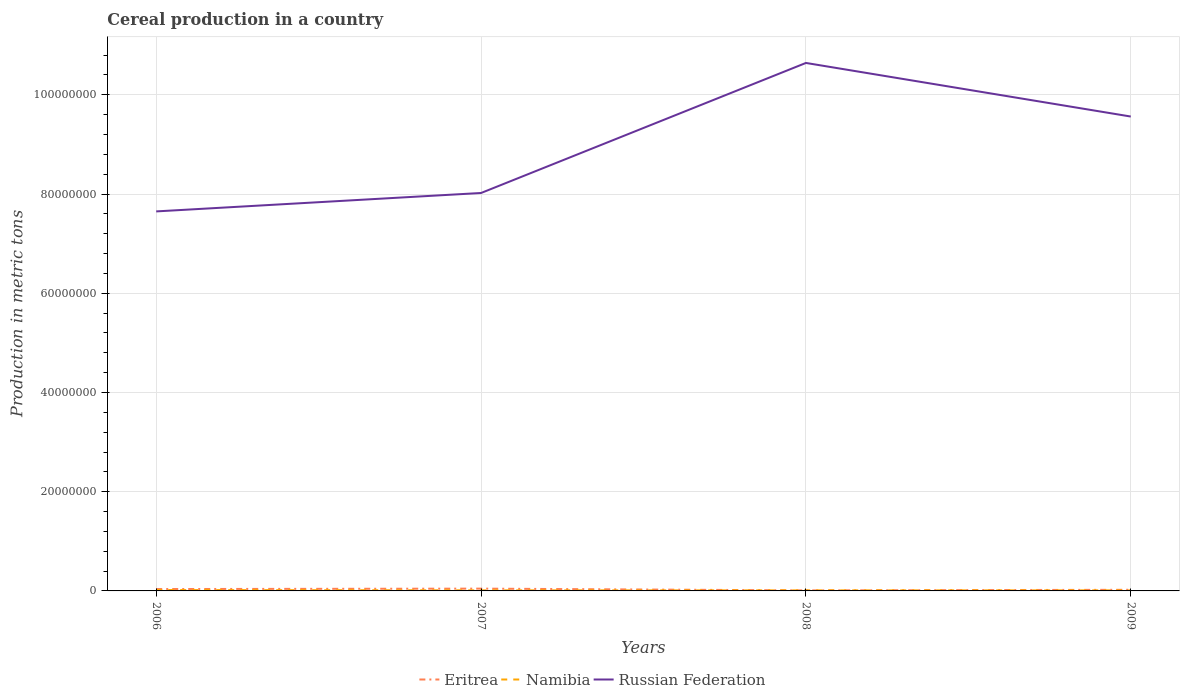Does the line corresponding to Eritrea intersect with the line corresponding to Russian Federation?
Provide a succinct answer. No. Across all years, what is the maximum total cereal production in Eritrea?
Your response must be concise. 1.06e+05. In which year was the total cereal production in Namibia maximum?
Your answer should be compact. 2009. What is the total total cereal production in Namibia in the graph?
Your answer should be compact. 7.09e+04. What is the difference between the highest and the second highest total cereal production in Russian Federation?
Give a very brief answer. 2.99e+07. What is the difference between the highest and the lowest total cereal production in Namibia?
Give a very brief answer. 1. Is the total cereal production in Eritrea strictly greater than the total cereal production in Russian Federation over the years?
Ensure brevity in your answer.  Yes. How many lines are there?
Your answer should be very brief. 3. How many years are there in the graph?
Your response must be concise. 4. Are the values on the major ticks of Y-axis written in scientific E-notation?
Your answer should be very brief. No. Does the graph contain any zero values?
Keep it short and to the point. No. Does the graph contain grids?
Keep it short and to the point. Yes. How many legend labels are there?
Give a very brief answer. 3. What is the title of the graph?
Make the answer very short. Cereal production in a country. Does "Monaco" appear as one of the legend labels in the graph?
Provide a short and direct response. No. What is the label or title of the X-axis?
Ensure brevity in your answer.  Years. What is the label or title of the Y-axis?
Ensure brevity in your answer.  Production in metric tons. What is the Production in metric tons in Eritrea in 2006?
Ensure brevity in your answer.  3.77e+05. What is the Production in metric tons in Namibia in 2006?
Your answer should be compact. 1.83e+05. What is the Production in metric tons in Russian Federation in 2006?
Provide a succinct answer. 7.65e+07. What is the Production in metric tons in Eritrea in 2007?
Give a very brief answer. 4.62e+05. What is the Production in metric tons of Namibia in 2007?
Your answer should be compact. 1.16e+05. What is the Production in metric tons in Russian Federation in 2007?
Your answer should be compact. 8.02e+07. What is the Production in metric tons in Eritrea in 2008?
Provide a short and direct response. 1.06e+05. What is the Production in metric tons in Namibia in 2008?
Your response must be concise. 1.13e+05. What is the Production in metric tons in Russian Federation in 2008?
Offer a very short reply. 1.06e+08. What is the Production in metric tons of Eritrea in 2009?
Provide a succinct answer. 2.27e+05. What is the Production in metric tons in Namibia in 2009?
Provide a succinct answer. 1.12e+05. What is the Production in metric tons in Russian Federation in 2009?
Keep it short and to the point. 9.56e+07. Across all years, what is the maximum Production in metric tons in Eritrea?
Ensure brevity in your answer.  4.62e+05. Across all years, what is the maximum Production in metric tons in Namibia?
Offer a terse response. 1.83e+05. Across all years, what is the maximum Production in metric tons in Russian Federation?
Provide a succinct answer. 1.06e+08. Across all years, what is the minimum Production in metric tons in Eritrea?
Give a very brief answer. 1.06e+05. Across all years, what is the minimum Production in metric tons in Namibia?
Provide a short and direct response. 1.12e+05. Across all years, what is the minimum Production in metric tons of Russian Federation?
Give a very brief answer. 7.65e+07. What is the total Production in metric tons of Eritrea in the graph?
Offer a terse response. 1.17e+06. What is the total Production in metric tons in Namibia in the graph?
Make the answer very short. 5.23e+05. What is the total Production in metric tons of Russian Federation in the graph?
Offer a terse response. 3.59e+08. What is the difference between the Production in metric tons of Eritrea in 2006 and that in 2007?
Your answer should be compact. -8.48e+04. What is the difference between the Production in metric tons in Namibia in 2006 and that in 2007?
Make the answer very short. 6.65e+04. What is the difference between the Production in metric tons of Russian Federation in 2006 and that in 2007?
Provide a succinct answer. -3.71e+06. What is the difference between the Production in metric tons in Eritrea in 2006 and that in 2008?
Your answer should be very brief. 2.71e+05. What is the difference between the Production in metric tons of Namibia in 2006 and that in 2008?
Provide a short and direct response. 7.01e+04. What is the difference between the Production in metric tons in Russian Federation in 2006 and that in 2008?
Your response must be concise. -2.99e+07. What is the difference between the Production in metric tons in Eritrea in 2006 and that in 2009?
Offer a terse response. 1.50e+05. What is the difference between the Production in metric tons in Namibia in 2006 and that in 2009?
Provide a succinct answer. 7.09e+04. What is the difference between the Production in metric tons of Russian Federation in 2006 and that in 2009?
Offer a very short reply. -1.91e+07. What is the difference between the Production in metric tons of Eritrea in 2007 and that in 2008?
Your response must be concise. 3.56e+05. What is the difference between the Production in metric tons in Namibia in 2007 and that in 2008?
Ensure brevity in your answer.  3603. What is the difference between the Production in metric tons of Russian Federation in 2007 and that in 2008?
Give a very brief answer. -2.62e+07. What is the difference between the Production in metric tons of Eritrea in 2007 and that in 2009?
Offer a very short reply. 2.35e+05. What is the difference between the Production in metric tons in Namibia in 2007 and that in 2009?
Keep it short and to the point. 4445. What is the difference between the Production in metric tons of Russian Federation in 2007 and that in 2009?
Offer a terse response. -1.54e+07. What is the difference between the Production in metric tons in Eritrea in 2008 and that in 2009?
Give a very brief answer. -1.21e+05. What is the difference between the Production in metric tons of Namibia in 2008 and that in 2009?
Give a very brief answer. 842. What is the difference between the Production in metric tons of Russian Federation in 2008 and that in 2009?
Make the answer very short. 1.08e+07. What is the difference between the Production in metric tons in Eritrea in 2006 and the Production in metric tons in Namibia in 2007?
Keep it short and to the point. 2.61e+05. What is the difference between the Production in metric tons of Eritrea in 2006 and the Production in metric tons of Russian Federation in 2007?
Keep it short and to the point. -7.98e+07. What is the difference between the Production in metric tons in Namibia in 2006 and the Production in metric tons in Russian Federation in 2007?
Provide a succinct answer. -8.00e+07. What is the difference between the Production in metric tons of Eritrea in 2006 and the Production in metric tons of Namibia in 2008?
Your answer should be compact. 2.65e+05. What is the difference between the Production in metric tons in Eritrea in 2006 and the Production in metric tons in Russian Federation in 2008?
Ensure brevity in your answer.  -1.06e+08. What is the difference between the Production in metric tons of Namibia in 2006 and the Production in metric tons of Russian Federation in 2008?
Make the answer very short. -1.06e+08. What is the difference between the Production in metric tons in Eritrea in 2006 and the Production in metric tons in Namibia in 2009?
Provide a short and direct response. 2.65e+05. What is the difference between the Production in metric tons in Eritrea in 2006 and the Production in metric tons in Russian Federation in 2009?
Ensure brevity in your answer.  -9.52e+07. What is the difference between the Production in metric tons of Namibia in 2006 and the Production in metric tons of Russian Federation in 2009?
Give a very brief answer. -9.54e+07. What is the difference between the Production in metric tons in Eritrea in 2007 and the Production in metric tons in Namibia in 2008?
Ensure brevity in your answer.  3.49e+05. What is the difference between the Production in metric tons in Eritrea in 2007 and the Production in metric tons in Russian Federation in 2008?
Keep it short and to the point. -1.06e+08. What is the difference between the Production in metric tons of Namibia in 2007 and the Production in metric tons of Russian Federation in 2008?
Ensure brevity in your answer.  -1.06e+08. What is the difference between the Production in metric tons in Eritrea in 2007 and the Production in metric tons in Namibia in 2009?
Ensure brevity in your answer.  3.50e+05. What is the difference between the Production in metric tons of Eritrea in 2007 and the Production in metric tons of Russian Federation in 2009?
Give a very brief answer. -9.52e+07. What is the difference between the Production in metric tons of Namibia in 2007 and the Production in metric tons of Russian Federation in 2009?
Give a very brief answer. -9.55e+07. What is the difference between the Production in metric tons of Eritrea in 2008 and the Production in metric tons of Namibia in 2009?
Keep it short and to the point. -5950. What is the difference between the Production in metric tons of Eritrea in 2008 and the Production in metric tons of Russian Federation in 2009?
Make the answer very short. -9.55e+07. What is the difference between the Production in metric tons of Namibia in 2008 and the Production in metric tons of Russian Federation in 2009?
Give a very brief answer. -9.55e+07. What is the average Production in metric tons in Eritrea per year?
Make the answer very short. 2.93e+05. What is the average Production in metric tons in Namibia per year?
Your answer should be very brief. 1.31e+05. What is the average Production in metric tons in Russian Federation per year?
Provide a succinct answer. 8.97e+07. In the year 2006, what is the difference between the Production in metric tons in Eritrea and Production in metric tons in Namibia?
Your response must be concise. 1.95e+05. In the year 2006, what is the difference between the Production in metric tons of Eritrea and Production in metric tons of Russian Federation?
Give a very brief answer. -7.61e+07. In the year 2006, what is the difference between the Production in metric tons of Namibia and Production in metric tons of Russian Federation?
Provide a short and direct response. -7.63e+07. In the year 2007, what is the difference between the Production in metric tons in Eritrea and Production in metric tons in Namibia?
Keep it short and to the point. 3.46e+05. In the year 2007, what is the difference between the Production in metric tons in Eritrea and Production in metric tons in Russian Federation?
Your answer should be compact. -7.97e+07. In the year 2007, what is the difference between the Production in metric tons of Namibia and Production in metric tons of Russian Federation?
Give a very brief answer. -8.01e+07. In the year 2008, what is the difference between the Production in metric tons in Eritrea and Production in metric tons in Namibia?
Provide a short and direct response. -6792. In the year 2008, what is the difference between the Production in metric tons in Eritrea and Production in metric tons in Russian Federation?
Your answer should be very brief. -1.06e+08. In the year 2008, what is the difference between the Production in metric tons in Namibia and Production in metric tons in Russian Federation?
Provide a short and direct response. -1.06e+08. In the year 2009, what is the difference between the Production in metric tons in Eritrea and Production in metric tons in Namibia?
Provide a short and direct response. 1.15e+05. In the year 2009, what is the difference between the Production in metric tons of Eritrea and Production in metric tons of Russian Federation?
Ensure brevity in your answer.  -9.54e+07. In the year 2009, what is the difference between the Production in metric tons in Namibia and Production in metric tons in Russian Federation?
Provide a short and direct response. -9.55e+07. What is the ratio of the Production in metric tons in Eritrea in 2006 to that in 2007?
Provide a succinct answer. 0.82. What is the ratio of the Production in metric tons in Namibia in 2006 to that in 2007?
Give a very brief answer. 1.57. What is the ratio of the Production in metric tons in Russian Federation in 2006 to that in 2007?
Your answer should be compact. 0.95. What is the ratio of the Production in metric tons in Eritrea in 2006 to that in 2008?
Your answer should be very brief. 3.57. What is the ratio of the Production in metric tons in Namibia in 2006 to that in 2008?
Ensure brevity in your answer.  1.62. What is the ratio of the Production in metric tons of Russian Federation in 2006 to that in 2008?
Make the answer very short. 0.72. What is the ratio of the Production in metric tons of Eritrea in 2006 to that in 2009?
Your answer should be compact. 1.66. What is the ratio of the Production in metric tons of Namibia in 2006 to that in 2009?
Give a very brief answer. 1.63. What is the ratio of the Production in metric tons in Russian Federation in 2006 to that in 2009?
Give a very brief answer. 0.8. What is the ratio of the Production in metric tons in Eritrea in 2007 to that in 2008?
Your answer should be very brief. 4.37. What is the ratio of the Production in metric tons of Namibia in 2007 to that in 2008?
Offer a very short reply. 1.03. What is the ratio of the Production in metric tons in Russian Federation in 2007 to that in 2008?
Offer a terse response. 0.75. What is the ratio of the Production in metric tons in Eritrea in 2007 to that in 2009?
Keep it short and to the point. 2.04. What is the ratio of the Production in metric tons in Namibia in 2007 to that in 2009?
Offer a terse response. 1.04. What is the ratio of the Production in metric tons of Russian Federation in 2007 to that in 2009?
Provide a short and direct response. 0.84. What is the ratio of the Production in metric tons of Eritrea in 2008 to that in 2009?
Offer a very short reply. 0.47. What is the ratio of the Production in metric tons of Namibia in 2008 to that in 2009?
Your answer should be very brief. 1.01. What is the ratio of the Production in metric tons in Russian Federation in 2008 to that in 2009?
Your response must be concise. 1.11. What is the difference between the highest and the second highest Production in metric tons in Eritrea?
Give a very brief answer. 8.48e+04. What is the difference between the highest and the second highest Production in metric tons of Namibia?
Your answer should be very brief. 6.65e+04. What is the difference between the highest and the second highest Production in metric tons in Russian Federation?
Your answer should be compact. 1.08e+07. What is the difference between the highest and the lowest Production in metric tons in Eritrea?
Provide a short and direct response. 3.56e+05. What is the difference between the highest and the lowest Production in metric tons of Namibia?
Keep it short and to the point. 7.09e+04. What is the difference between the highest and the lowest Production in metric tons in Russian Federation?
Provide a succinct answer. 2.99e+07. 